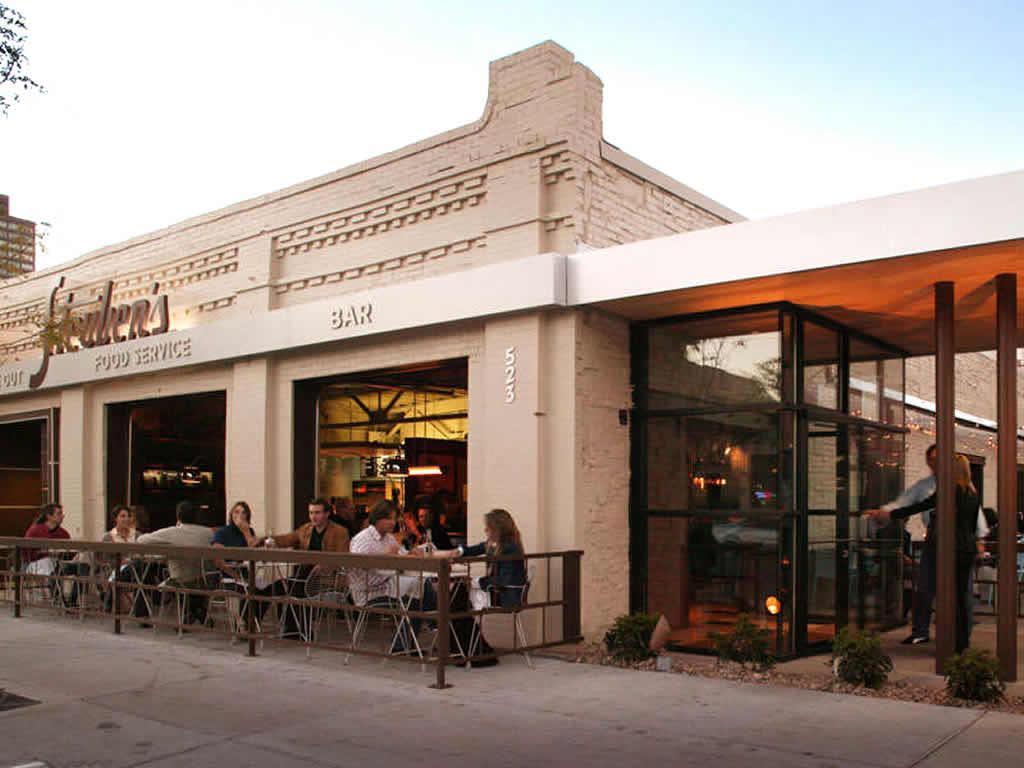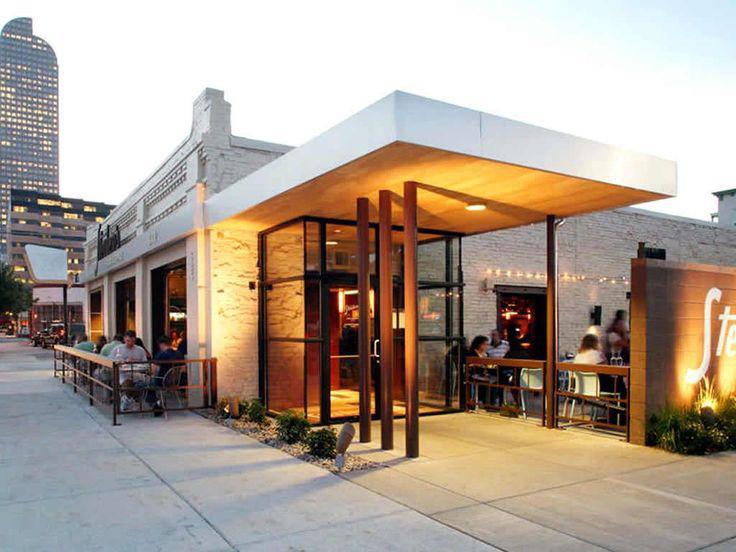The first image is the image on the left, the second image is the image on the right. For the images displayed, is the sentence "The numbers for the address can be seen outside the building in one of the images." factually correct? Answer yes or no. Yes. 